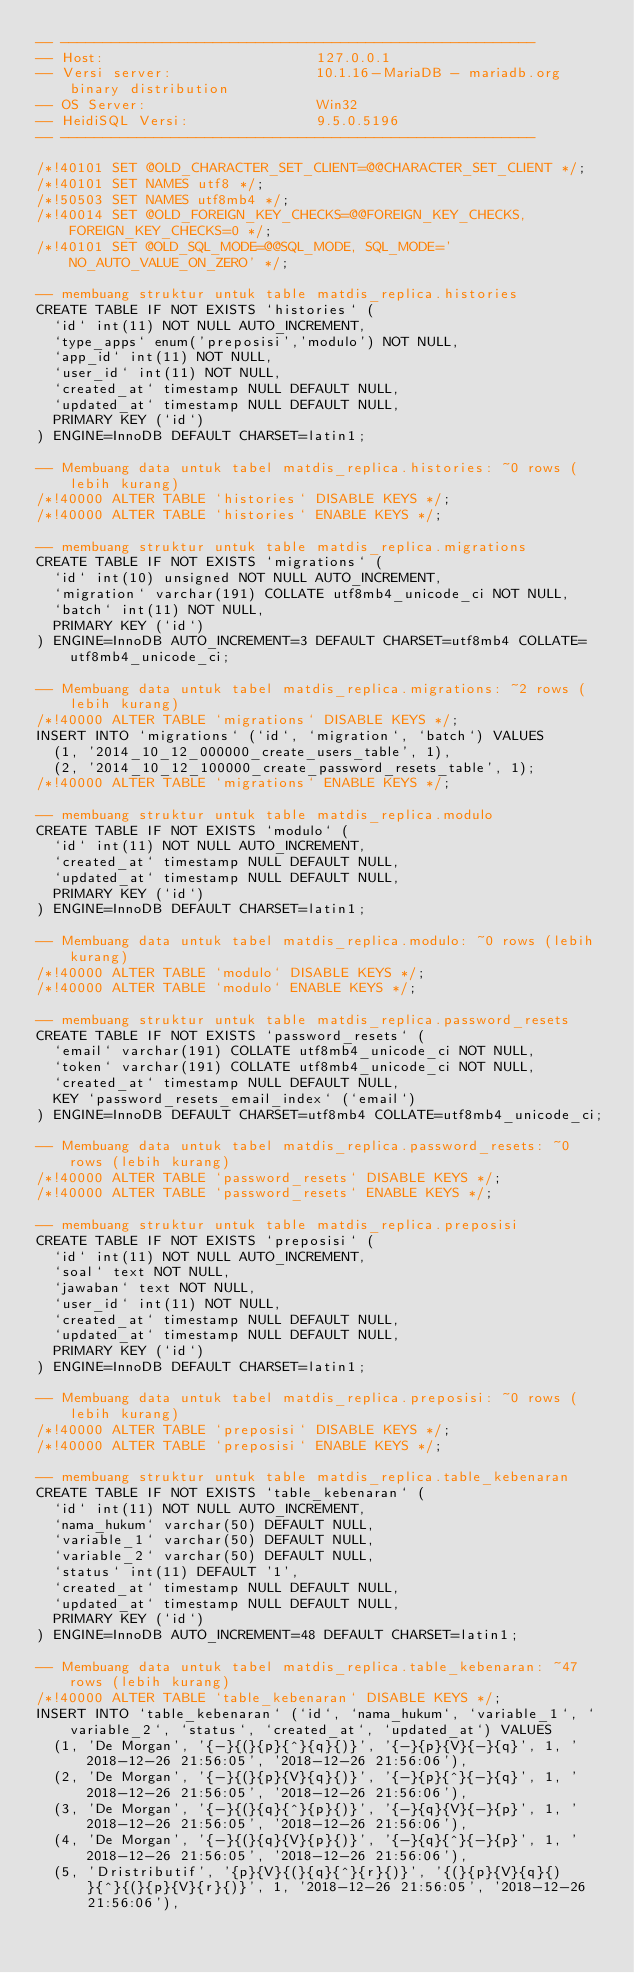<code> <loc_0><loc_0><loc_500><loc_500><_SQL_>-- --------------------------------------------------------
-- Host:                         127.0.0.1
-- Versi server:                 10.1.16-MariaDB - mariadb.org binary distribution
-- OS Server:                    Win32
-- HeidiSQL Versi:               9.5.0.5196
-- --------------------------------------------------------

/*!40101 SET @OLD_CHARACTER_SET_CLIENT=@@CHARACTER_SET_CLIENT */;
/*!40101 SET NAMES utf8 */;
/*!50503 SET NAMES utf8mb4 */;
/*!40014 SET @OLD_FOREIGN_KEY_CHECKS=@@FOREIGN_KEY_CHECKS, FOREIGN_KEY_CHECKS=0 */;
/*!40101 SET @OLD_SQL_MODE=@@SQL_MODE, SQL_MODE='NO_AUTO_VALUE_ON_ZERO' */;

-- membuang struktur untuk table matdis_replica.histories
CREATE TABLE IF NOT EXISTS `histories` (
  `id` int(11) NOT NULL AUTO_INCREMENT,
  `type_apps` enum('preposisi','modulo') NOT NULL,
  `app_id` int(11) NOT NULL,
  `user_id` int(11) NOT NULL,
  `created_at` timestamp NULL DEFAULT NULL,
  `updated_at` timestamp NULL DEFAULT NULL,
  PRIMARY KEY (`id`)
) ENGINE=InnoDB DEFAULT CHARSET=latin1;

-- Membuang data untuk tabel matdis_replica.histories: ~0 rows (lebih kurang)
/*!40000 ALTER TABLE `histories` DISABLE KEYS */;
/*!40000 ALTER TABLE `histories` ENABLE KEYS */;

-- membuang struktur untuk table matdis_replica.migrations
CREATE TABLE IF NOT EXISTS `migrations` (
  `id` int(10) unsigned NOT NULL AUTO_INCREMENT,
  `migration` varchar(191) COLLATE utf8mb4_unicode_ci NOT NULL,
  `batch` int(11) NOT NULL,
  PRIMARY KEY (`id`)
) ENGINE=InnoDB AUTO_INCREMENT=3 DEFAULT CHARSET=utf8mb4 COLLATE=utf8mb4_unicode_ci;

-- Membuang data untuk tabel matdis_replica.migrations: ~2 rows (lebih kurang)
/*!40000 ALTER TABLE `migrations` DISABLE KEYS */;
INSERT INTO `migrations` (`id`, `migration`, `batch`) VALUES
	(1, '2014_10_12_000000_create_users_table', 1),
	(2, '2014_10_12_100000_create_password_resets_table', 1);
/*!40000 ALTER TABLE `migrations` ENABLE KEYS */;

-- membuang struktur untuk table matdis_replica.modulo
CREATE TABLE IF NOT EXISTS `modulo` (
  `id` int(11) NOT NULL AUTO_INCREMENT,
  `created_at` timestamp NULL DEFAULT NULL,
  `updated_at` timestamp NULL DEFAULT NULL,
  PRIMARY KEY (`id`)
) ENGINE=InnoDB DEFAULT CHARSET=latin1;

-- Membuang data untuk tabel matdis_replica.modulo: ~0 rows (lebih kurang)
/*!40000 ALTER TABLE `modulo` DISABLE KEYS */;
/*!40000 ALTER TABLE `modulo` ENABLE KEYS */;

-- membuang struktur untuk table matdis_replica.password_resets
CREATE TABLE IF NOT EXISTS `password_resets` (
  `email` varchar(191) COLLATE utf8mb4_unicode_ci NOT NULL,
  `token` varchar(191) COLLATE utf8mb4_unicode_ci NOT NULL,
  `created_at` timestamp NULL DEFAULT NULL,
  KEY `password_resets_email_index` (`email`)
) ENGINE=InnoDB DEFAULT CHARSET=utf8mb4 COLLATE=utf8mb4_unicode_ci;

-- Membuang data untuk tabel matdis_replica.password_resets: ~0 rows (lebih kurang)
/*!40000 ALTER TABLE `password_resets` DISABLE KEYS */;
/*!40000 ALTER TABLE `password_resets` ENABLE KEYS */;

-- membuang struktur untuk table matdis_replica.preposisi
CREATE TABLE IF NOT EXISTS `preposisi` (
  `id` int(11) NOT NULL AUTO_INCREMENT,
  `soal` text NOT NULL,
  `jawaban` text NOT NULL,
  `user_id` int(11) NOT NULL,
  `created_at` timestamp NULL DEFAULT NULL,
  `updated_at` timestamp NULL DEFAULT NULL,
  PRIMARY KEY (`id`)
) ENGINE=InnoDB DEFAULT CHARSET=latin1;

-- Membuang data untuk tabel matdis_replica.preposisi: ~0 rows (lebih kurang)
/*!40000 ALTER TABLE `preposisi` DISABLE KEYS */;
/*!40000 ALTER TABLE `preposisi` ENABLE KEYS */;

-- membuang struktur untuk table matdis_replica.table_kebenaran
CREATE TABLE IF NOT EXISTS `table_kebenaran` (
  `id` int(11) NOT NULL AUTO_INCREMENT,
  `nama_hukum` varchar(50) DEFAULT NULL,
  `variable_1` varchar(50) DEFAULT NULL,
  `variable_2` varchar(50) DEFAULT NULL,
  `status` int(11) DEFAULT '1',
  `created_at` timestamp NULL DEFAULT NULL,
  `updated_at` timestamp NULL DEFAULT NULL,
  PRIMARY KEY (`id`)
) ENGINE=InnoDB AUTO_INCREMENT=48 DEFAULT CHARSET=latin1;

-- Membuang data untuk tabel matdis_replica.table_kebenaran: ~47 rows (lebih kurang)
/*!40000 ALTER TABLE `table_kebenaran` DISABLE KEYS */;
INSERT INTO `table_kebenaran` (`id`, `nama_hukum`, `variable_1`, `variable_2`, `status`, `created_at`, `updated_at`) VALUES
	(1, 'De Morgan', '{-}{(}{p}{^}{q}{)}', '{-}{p}{V}{-}{q}', 1, '2018-12-26 21:56:05', '2018-12-26 21:56:06'),
	(2, 'De Morgan', '{-}{(}{p}{V}{q}{)}', '{-}{p}{^}{-}{q}', 1, '2018-12-26 21:56:05', '2018-12-26 21:56:06'),
	(3, 'De Morgan', '{-}{(}{q}{^}{p}{)}', '{-}{q}{V}{-}{p}', 1, '2018-12-26 21:56:05', '2018-12-26 21:56:06'),
	(4, 'De Morgan', '{-}{(}{q}{V}{p}{)}', '{-}{q}{^}{-}{p}', 1, '2018-12-26 21:56:05', '2018-12-26 21:56:06'),
	(5, 'Dristributif', '{p}{V}{(}{q}{^}{r}{)}', '{(}{p}{V}{q}{)}{^}{(}{p}{V}{r}{)}', 1, '2018-12-26 21:56:05', '2018-12-26 21:56:06'),</code> 